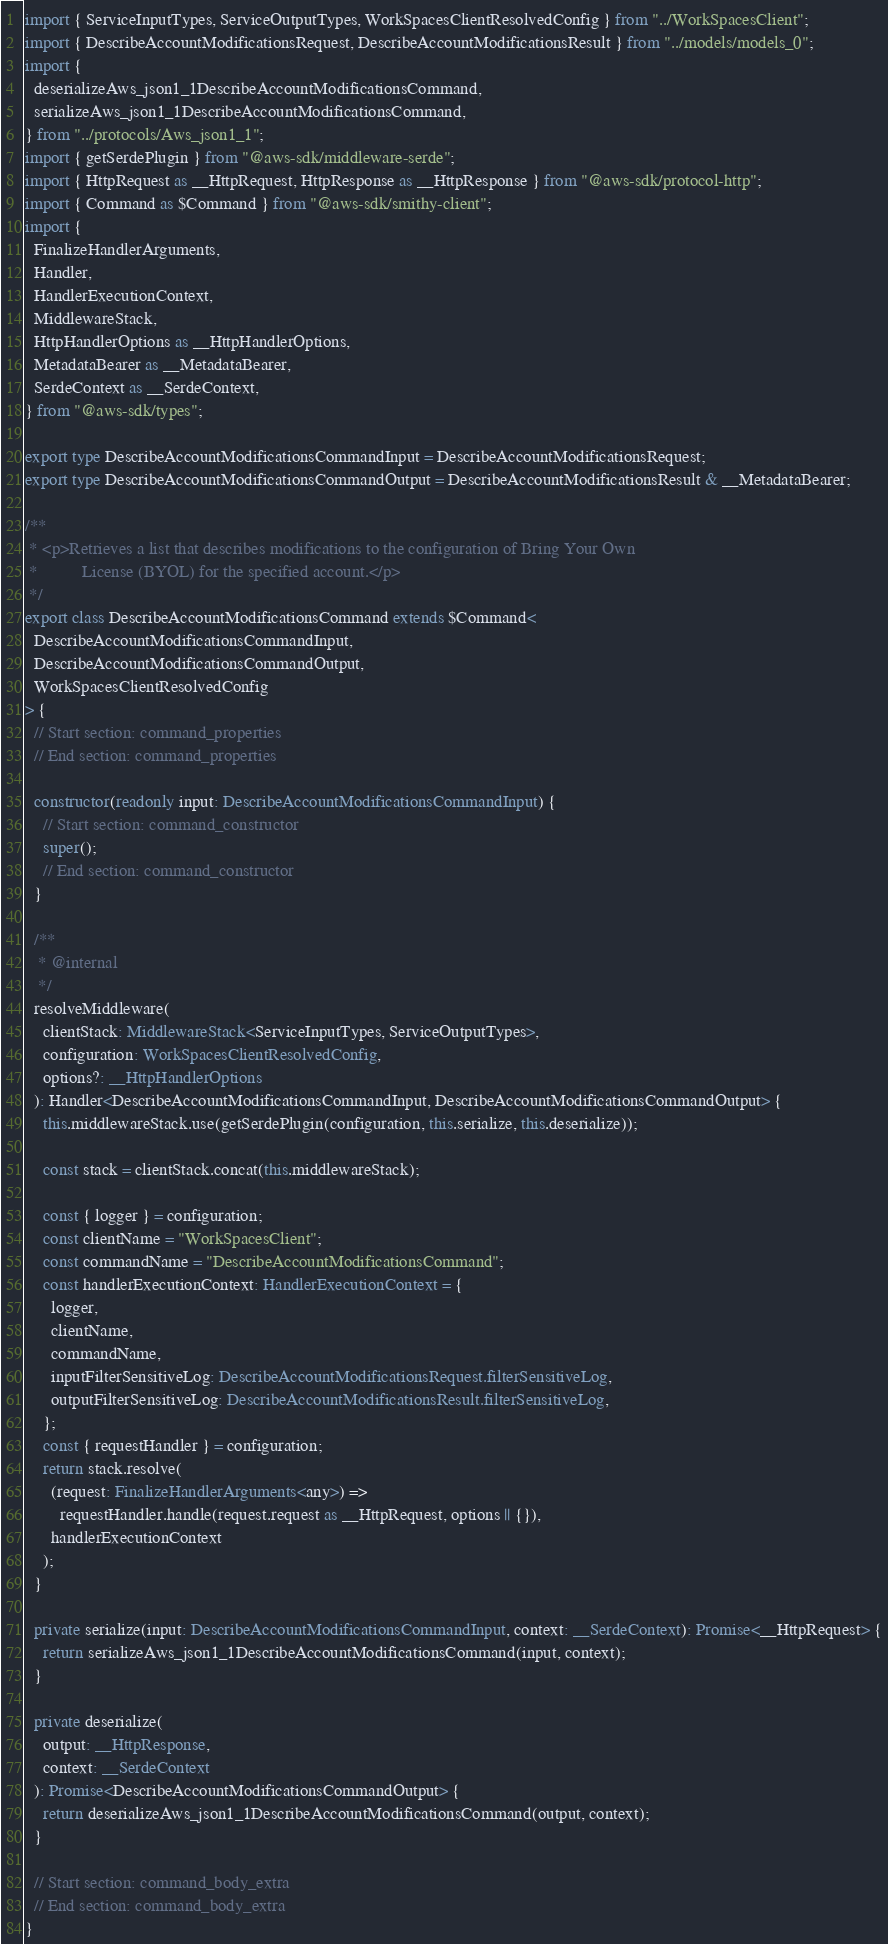Convert code to text. <code><loc_0><loc_0><loc_500><loc_500><_TypeScript_>import { ServiceInputTypes, ServiceOutputTypes, WorkSpacesClientResolvedConfig } from "../WorkSpacesClient";
import { DescribeAccountModificationsRequest, DescribeAccountModificationsResult } from "../models/models_0";
import {
  deserializeAws_json1_1DescribeAccountModificationsCommand,
  serializeAws_json1_1DescribeAccountModificationsCommand,
} from "../protocols/Aws_json1_1";
import { getSerdePlugin } from "@aws-sdk/middleware-serde";
import { HttpRequest as __HttpRequest, HttpResponse as __HttpResponse } from "@aws-sdk/protocol-http";
import { Command as $Command } from "@aws-sdk/smithy-client";
import {
  FinalizeHandlerArguments,
  Handler,
  HandlerExecutionContext,
  MiddlewareStack,
  HttpHandlerOptions as __HttpHandlerOptions,
  MetadataBearer as __MetadataBearer,
  SerdeContext as __SerdeContext,
} from "@aws-sdk/types";

export type DescribeAccountModificationsCommandInput = DescribeAccountModificationsRequest;
export type DescribeAccountModificationsCommandOutput = DescribeAccountModificationsResult & __MetadataBearer;

/**
 * <p>Retrieves a list that describes modifications to the configuration of Bring Your Own
 *          License (BYOL) for the specified account.</p>
 */
export class DescribeAccountModificationsCommand extends $Command<
  DescribeAccountModificationsCommandInput,
  DescribeAccountModificationsCommandOutput,
  WorkSpacesClientResolvedConfig
> {
  // Start section: command_properties
  // End section: command_properties

  constructor(readonly input: DescribeAccountModificationsCommandInput) {
    // Start section: command_constructor
    super();
    // End section: command_constructor
  }

  /**
   * @internal
   */
  resolveMiddleware(
    clientStack: MiddlewareStack<ServiceInputTypes, ServiceOutputTypes>,
    configuration: WorkSpacesClientResolvedConfig,
    options?: __HttpHandlerOptions
  ): Handler<DescribeAccountModificationsCommandInput, DescribeAccountModificationsCommandOutput> {
    this.middlewareStack.use(getSerdePlugin(configuration, this.serialize, this.deserialize));

    const stack = clientStack.concat(this.middlewareStack);

    const { logger } = configuration;
    const clientName = "WorkSpacesClient";
    const commandName = "DescribeAccountModificationsCommand";
    const handlerExecutionContext: HandlerExecutionContext = {
      logger,
      clientName,
      commandName,
      inputFilterSensitiveLog: DescribeAccountModificationsRequest.filterSensitiveLog,
      outputFilterSensitiveLog: DescribeAccountModificationsResult.filterSensitiveLog,
    };
    const { requestHandler } = configuration;
    return stack.resolve(
      (request: FinalizeHandlerArguments<any>) =>
        requestHandler.handle(request.request as __HttpRequest, options || {}),
      handlerExecutionContext
    );
  }

  private serialize(input: DescribeAccountModificationsCommandInput, context: __SerdeContext): Promise<__HttpRequest> {
    return serializeAws_json1_1DescribeAccountModificationsCommand(input, context);
  }

  private deserialize(
    output: __HttpResponse,
    context: __SerdeContext
  ): Promise<DescribeAccountModificationsCommandOutput> {
    return deserializeAws_json1_1DescribeAccountModificationsCommand(output, context);
  }

  // Start section: command_body_extra
  // End section: command_body_extra
}
</code> 